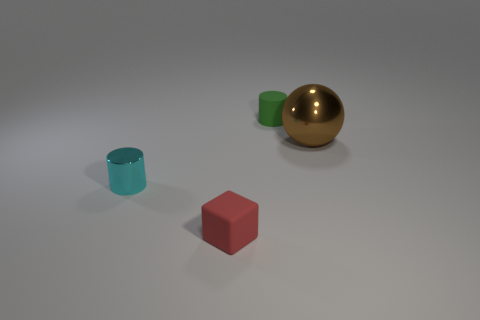If the red cube were to be placed on top of the green cylinder, how would their sizes compare? If the red cube were placed on top of the green cylinder, the cube would likely cover the cylinder's top completely, suggesting that the cube's side length is similar to or slightly larger than the diameter of the cylinder's top face. The cube's edges would likely extend just beyond the edges of the cylinder. 